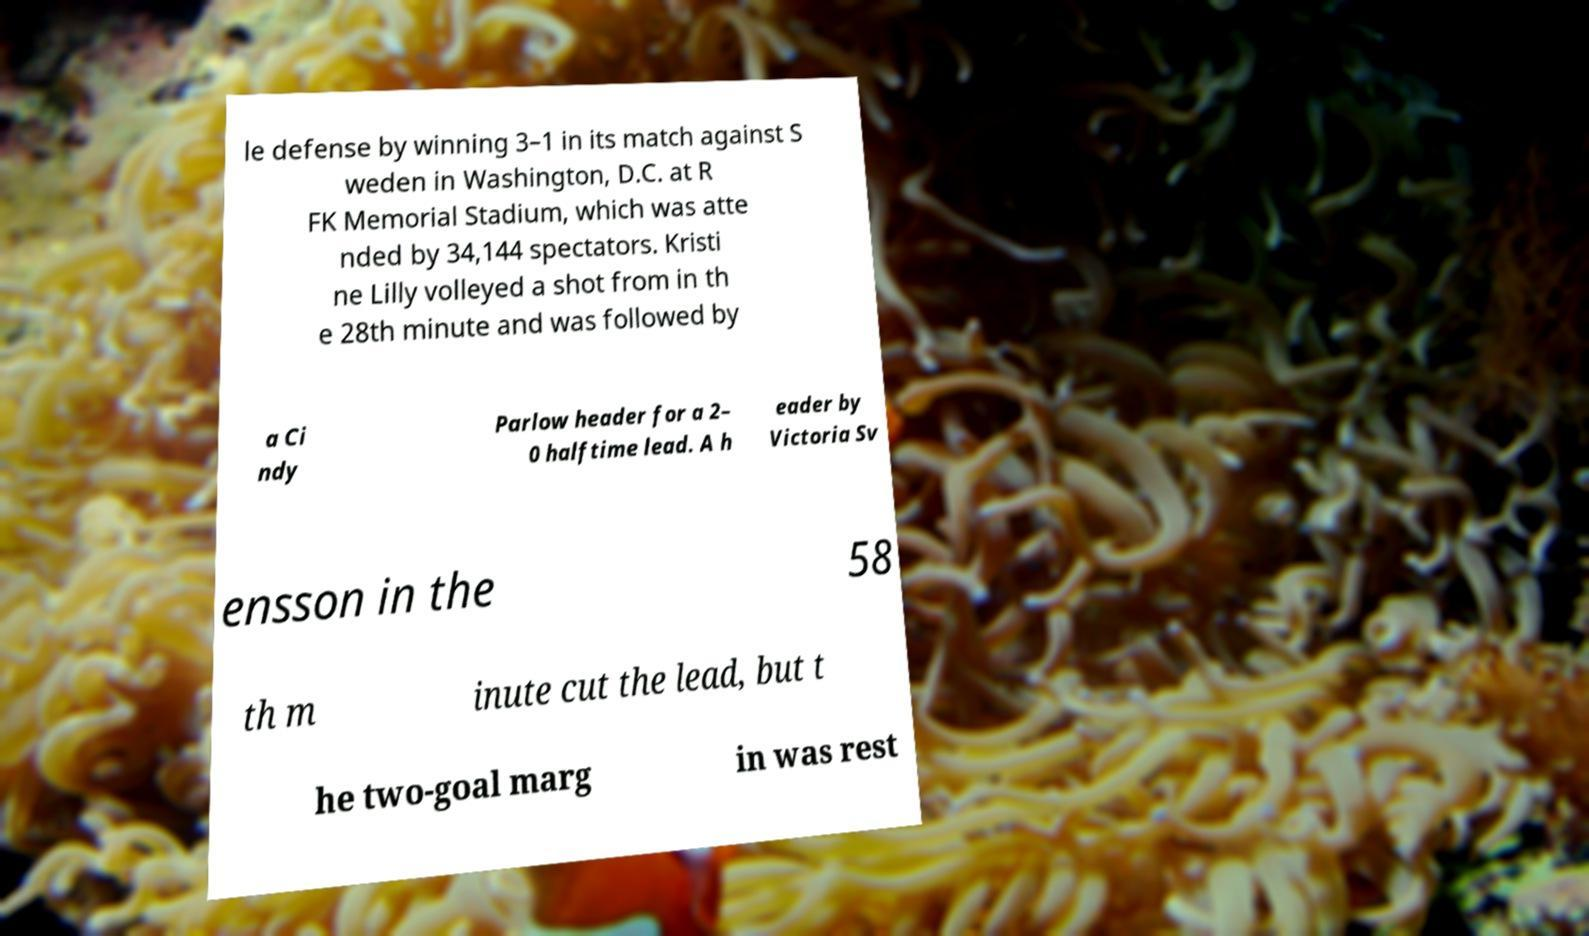Can you accurately transcribe the text from the provided image for me? le defense by winning 3–1 in its match against S weden in Washington, D.C. at R FK Memorial Stadium, which was atte nded by 34,144 spectators. Kristi ne Lilly volleyed a shot from in th e 28th minute and was followed by a Ci ndy Parlow header for a 2– 0 halftime lead. A h eader by Victoria Sv ensson in the 58 th m inute cut the lead, but t he two-goal marg in was rest 